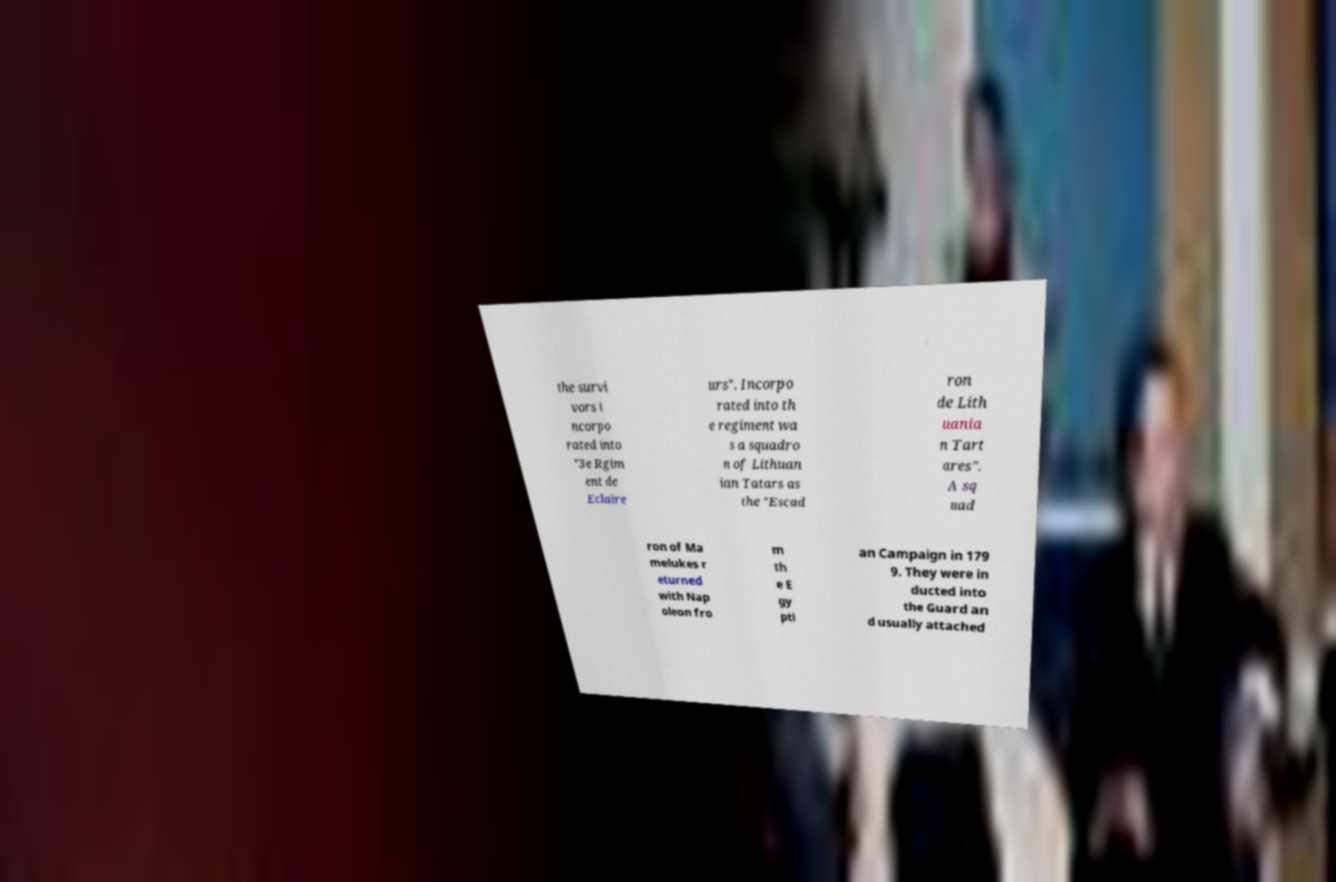Can you read and provide the text displayed in the image?This photo seems to have some interesting text. Can you extract and type it out for me? the survi vors i ncorpo rated into "3e Rgim ent de Eclaire urs". Incorpo rated into th e regiment wa s a squadro n of Lithuan ian Tatars as the "Escad ron de Lith uania n Tart ares". A sq uad ron of Ma melukes r eturned with Nap oleon fro m th e E gy pti an Campaign in 179 9. They were in ducted into the Guard an d usually attached 